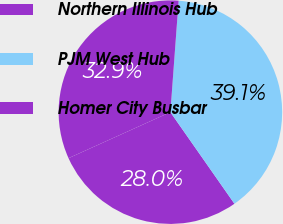Convert chart. <chart><loc_0><loc_0><loc_500><loc_500><pie_chart><fcel>Northern Illinois Hub<fcel>PJM West Hub<fcel>Homer City Busbar<nl><fcel>27.96%<fcel>39.11%<fcel>32.93%<nl></chart> 